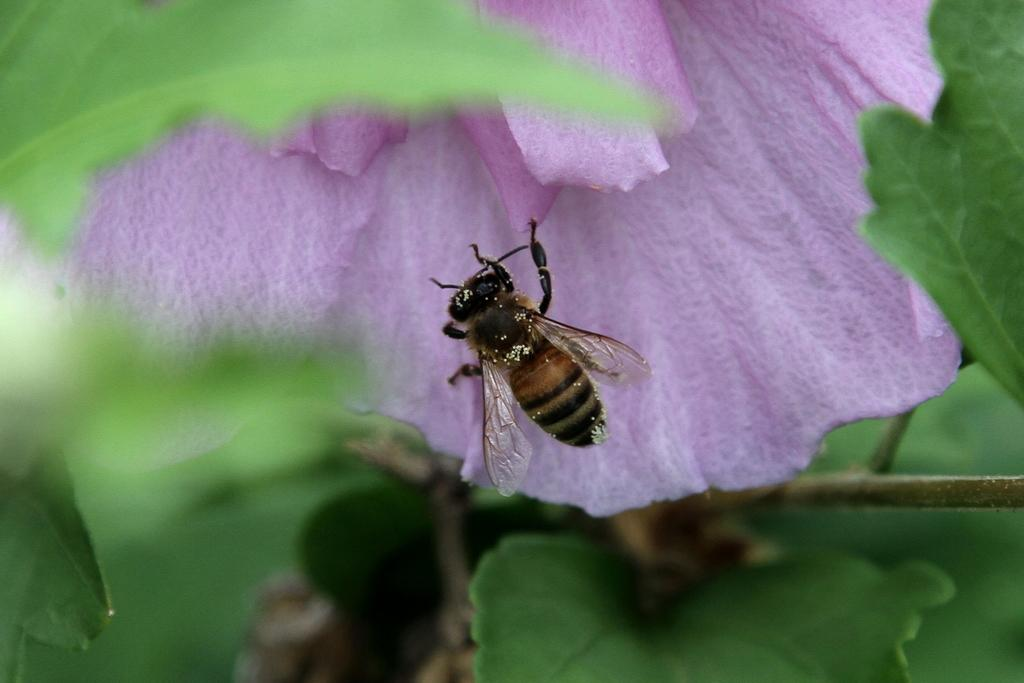What is the main subject of the image? There is a honey bee on a flower petal in the image. Can you describe the quality of the image? The image is slightly blurred. What else can be seen in the image besides the honey bee? Leaves are visible in the image. What type of stamp can be seen on the honey bee's wings in the image? There is no stamp present on the honey bee's wings in the image. Is there a river visible in the image? No, there is no river present in the image. 